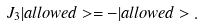<formula> <loc_0><loc_0><loc_500><loc_500>J _ { 3 } | a l l o w e d > = - | a l l o w e d > .</formula> 